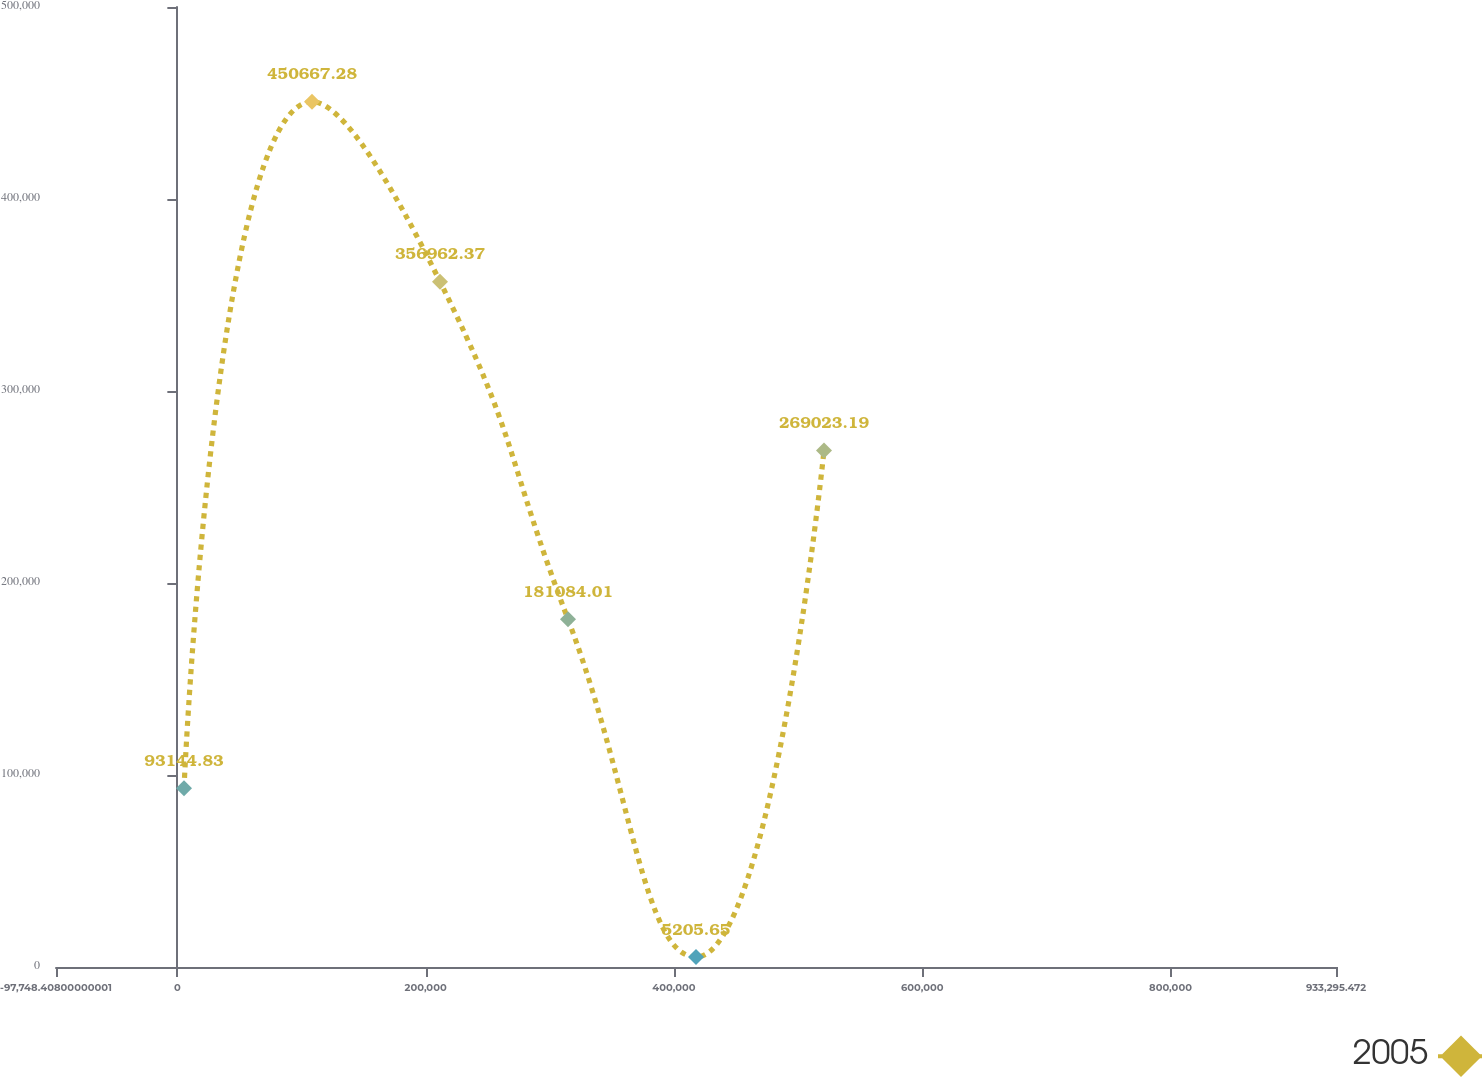Convert chart to OTSL. <chart><loc_0><loc_0><loc_500><loc_500><line_chart><ecel><fcel>2005<nl><fcel>5355.98<fcel>93144.8<nl><fcel>108460<fcel>450667<nl><fcel>211565<fcel>356962<nl><fcel>314669<fcel>181084<nl><fcel>417774<fcel>5205.65<nl><fcel>520878<fcel>269023<nl><fcel>1.0364e+06<fcel>884597<nl></chart> 